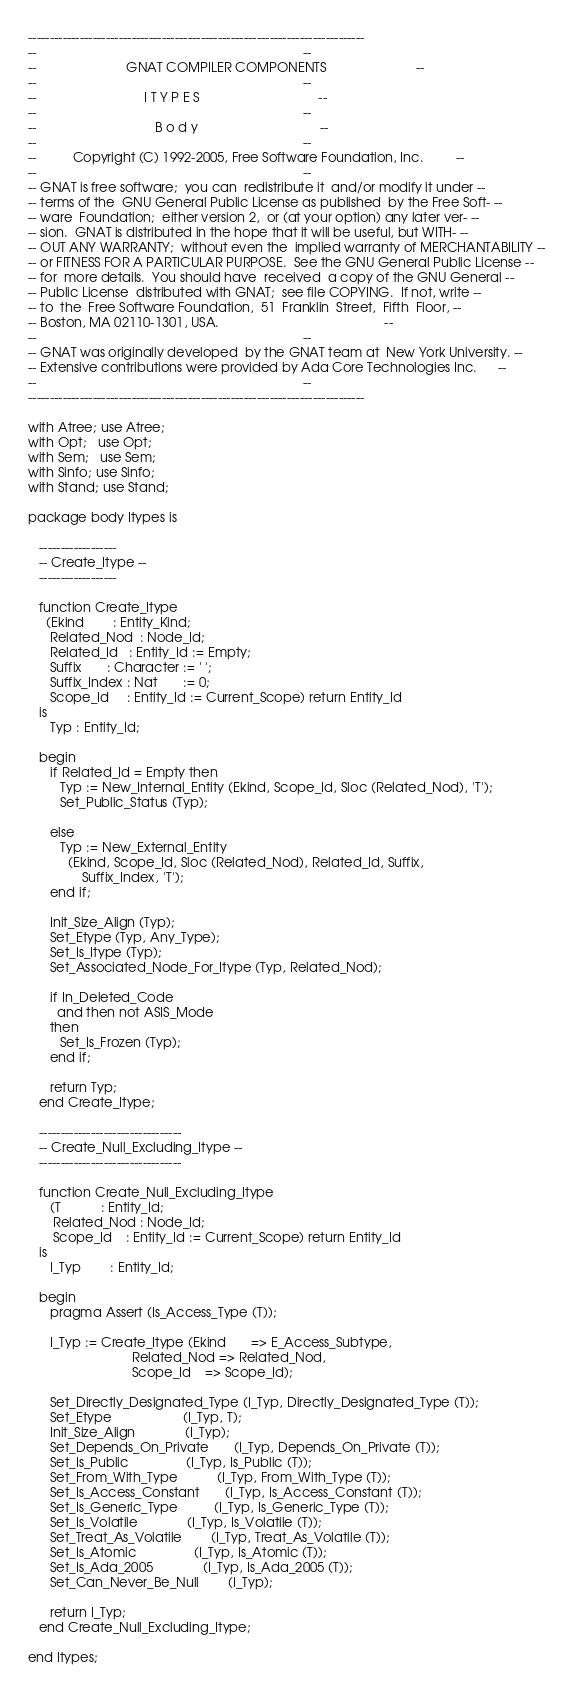<code> <loc_0><loc_0><loc_500><loc_500><_Ada_>------------------------------------------------------------------------------
--                                                                          --
--                         GNAT COMPILER COMPONENTS                         --
--                                                                          --
--                              I T Y P E S                                 --
--                                                                          --
--                                 B o d y                                  --
--                                                                          --
--          Copyright (C) 1992-2005, Free Software Foundation, Inc.         --
--                                                                          --
-- GNAT is free software;  you can  redistribute it  and/or modify it under --
-- terms of the  GNU General Public License as published  by the Free Soft- --
-- ware  Foundation;  either version 2,  or (at your option) any later ver- --
-- sion.  GNAT is distributed in the hope that it will be useful, but WITH- --
-- OUT ANY WARRANTY;  without even the  implied warranty of MERCHANTABILITY --
-- or FITNESS FOR A PARTICULAR PURPOSE.  See the GNU General Public License --
-- for  more details.  You should have  received  a copy of the GNU General --
-- Public License  distributed with GNAT;  see file COPYING.  If not, write --
-- to  the  Free Software Foundation,  51  Franklin  Street,  Fifth  Floor, --
-- Boston, MA 02110-1301, USA.                                              --
--                                                                          --
-- GNAT was originally developed  by the GNAT team at  New York University. --
-- Extensive contributions were provided by Ada Core Technologies Inc.      --
--                                                                          --
------------------------------------------------------------------------------

with Atree; use Atree;
with Opt;   use Opt;
with Sem;   use Sem;
with Sinfo; use Sinfo;
with Stand; use Stand;

package body Itypes is

   ------------------
   -- Create_Itype --
   ------------------

   function Create_Itype
     (Ekind        : Entity_Kind;
      Related_Nod  : Node_Id;
      Related_Id   : Entity_Id := Empty;
      Suffix       : Character := ' ';
      Suffix_Index : Nat       := 0;
      Scope_Id     : Entity_Id := Current_Scope) return Entity_Id
   is
      Typ : Entity_Id;

   begin
      if Related_Id = Empty then
         Typ := New_Internal_Entity (Ekind, Scope_Id, Sloc (Related_Nod), 'T');
         Set_Public_Status (Typ);

      else
         Typ := New_External_Entity
           (Ekind, Scope_Id, Sloc (Related_Nod), Related_Id, Suffix,
               Suffix_Index, 'T');
      end if;

      Init_Size_Align (Typ);
      Set_Etype (Typ, Any_Type);
      Set_Is_Itype (Typ);
      Set_Associated_Node_For_Itype (Typ, Related_Nod);

      if In_Deleted_Code
        and then not ASIS_Mode
      then
         Set_Is_Frozen (Typ);
      end if;

      return Typ;
   end Create_Itype;

   ---------------------------------
   -- Create_Null_Excluding_Itype --
   ---------------------------------

   function Create_Null_Excluding_Itype
      (T           : Entity_Id;
       Related_Nod : Node_Id;
       Scope_Id    : Entity_Id := Current_Scope) return Entity_Id
   is
      I_Typ        : Entity_Id;

   begin
      pragma Assert (Is_Access_Type (T));

      I_Typ := Create_Itype (Ekind       => E_Access_Subtype,
                             Related_Nod => Related_Nod,
                             Scope_Id    => Scope_Id);

      Set_Directly_Designated_Type (I_Typ, Directly_Designated_Type (T));
      Set_Etype                    (I_Typ, T);
      Init_Size_Align              (I_Typ);
      Set_Depends_On_Private       (I_Typ, Depends_On_Private (T));
      Set_Is_Public                (I_Typ, Is_Public (T));
      Set_From_With_Type           (I_Typ, From_With_Type (T));
      Set_Is_Access_Constant       (I_Typ, Is_Access_Constant (T));
      Set_Is_Generic_Type          (I_Typ, Is_Generic_Type (T));
      Set_Is_Volatile              (I_Typ, Is_Volatile (T));
      Set_Treat_As_Volatile        (I_Typ, Treat_As_Volatile (T));
      Set_Is_Atomic                (I_Typ, Is_Atomic (T));
      Set_Is_Ada_2005              (I_Typ, Is_Ada_2005 (T));
      Set_Can_Never_Be_Null        (I_Typ);

      return I_Typ;
   end Create_Null_Excluding_Itype;

end Itypes;
</code> 